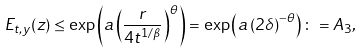Convert formula to latex. <formula><loc_0><loc_0><loc_500><loc_500>E _ { t , y } ( z ) \leq \exp \left ( a \left ( \frac { r } { 4 t ^ { 1 / \beta } } \right ) ^ { \theta } \right ) = \exp \left ( a \left ( 2 \delta \right ) ^ { - \theta } \right ) \colon = A _ { 3 } ,</formula> 